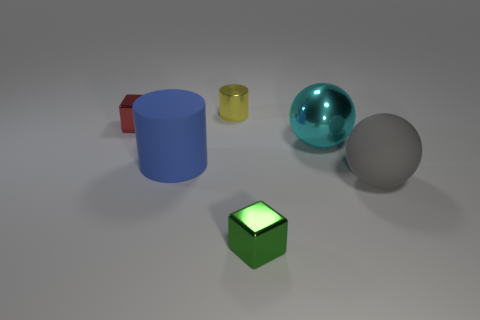Add 2 large cyan metal spheres. How many objects exist? 8 Subtract all blocks. How many objects are left? 4 Add 3 small blocks. How many small blocks exist? 5 Subtract 0 green cylinders. How many objects are left? 6 Subtract all green metallic objects. Subtract all small green things. How many objects are left? 4 Add 4 tiny red cubes. How many tiny red cubes are left? 5 